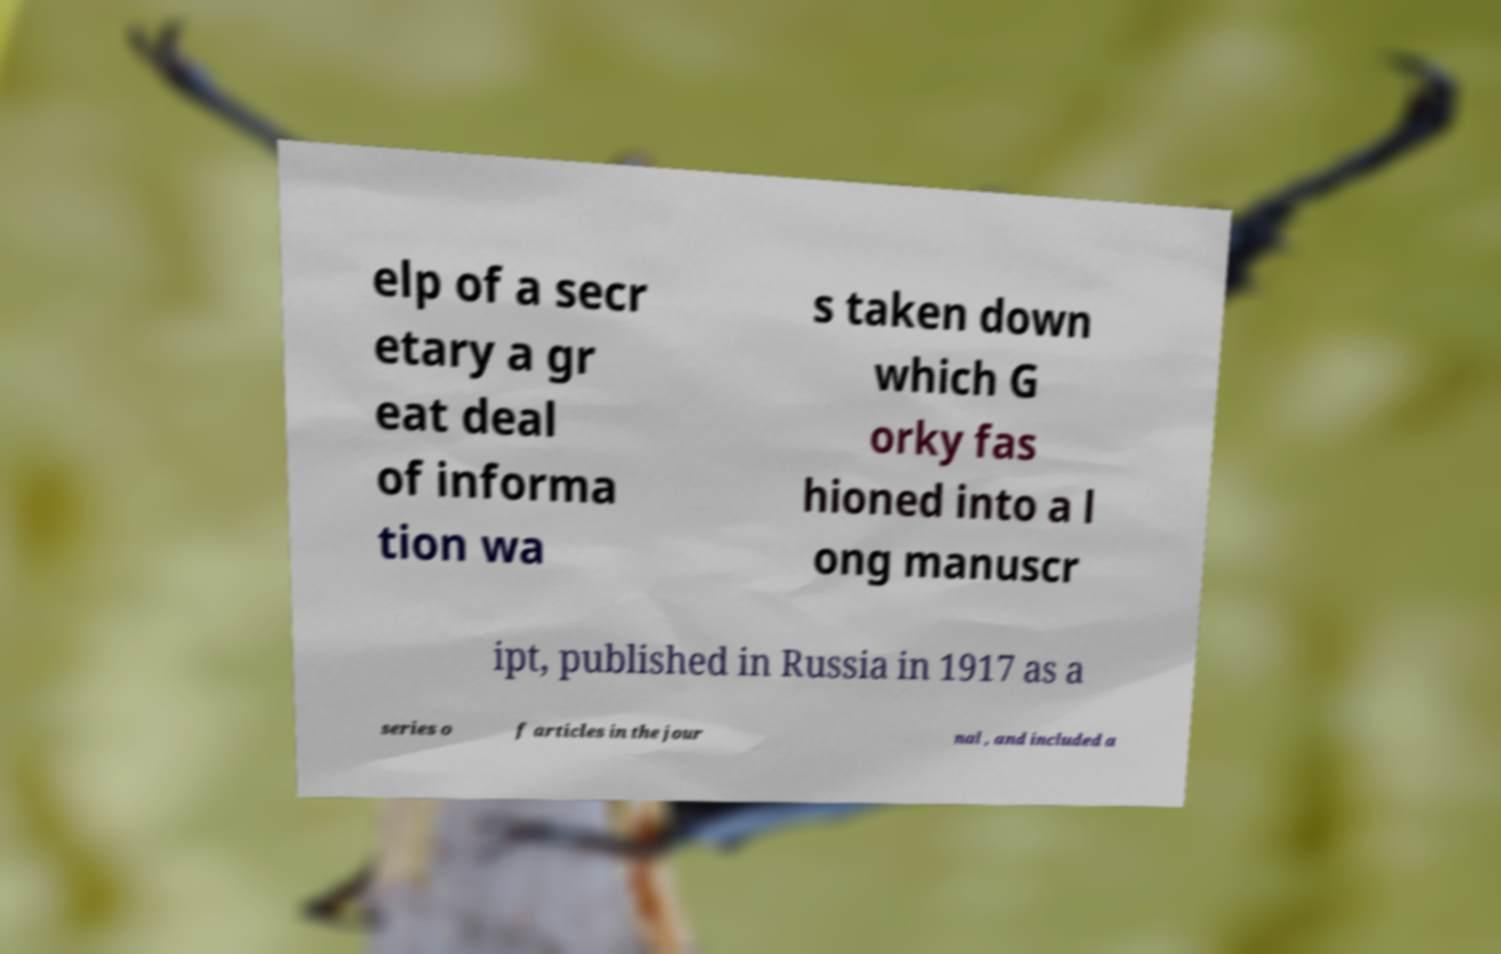Can you read and provide the text displayed in the image?This photo seems to have some interesting text. Can you extract and type it out for me? elp of a secr etary a gr eat deal of informa tion wa s taken down which G orky fas hioned into a l ong manuscr ipt, published in Russia in 1917 as a series o f articles in the jour nal , and included a 